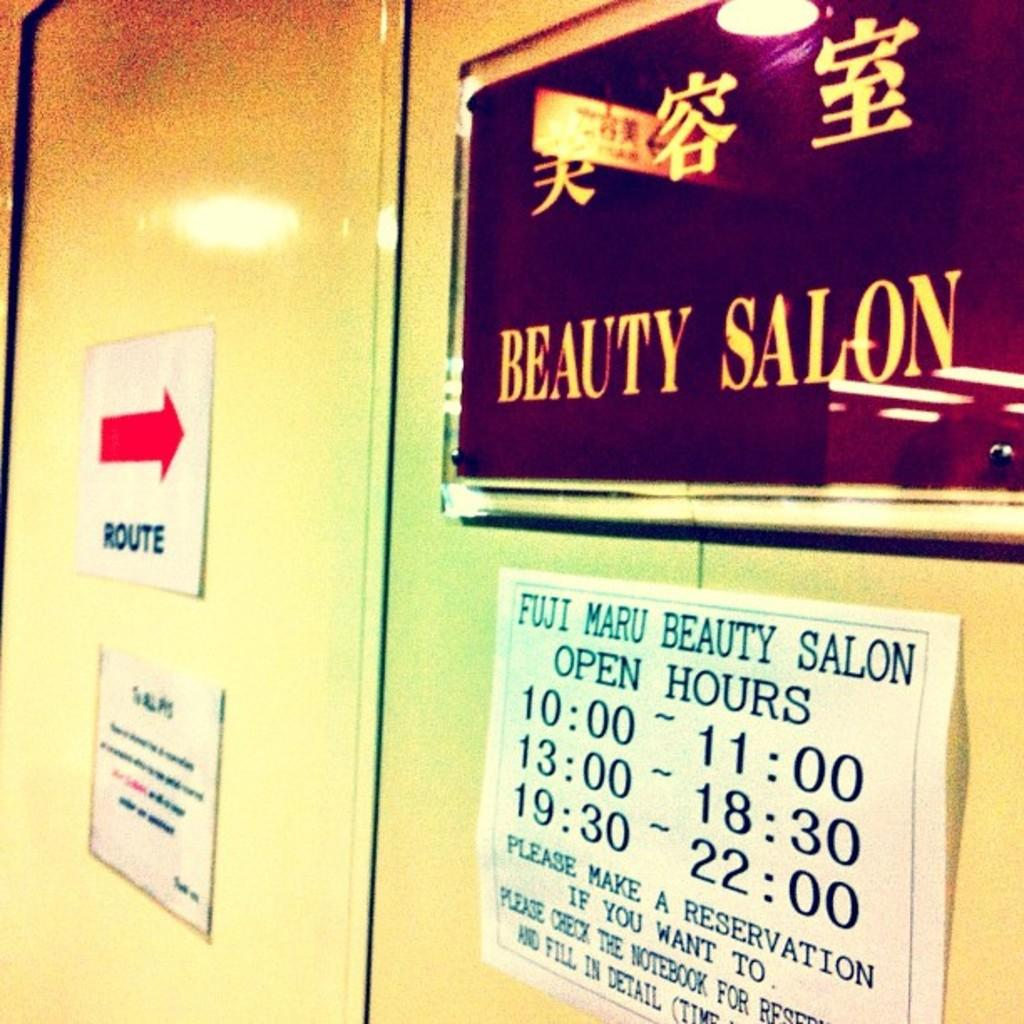<image>
Render a clear and concise summary of the photo. A sign for a beauty salon includes their hours of operation. 